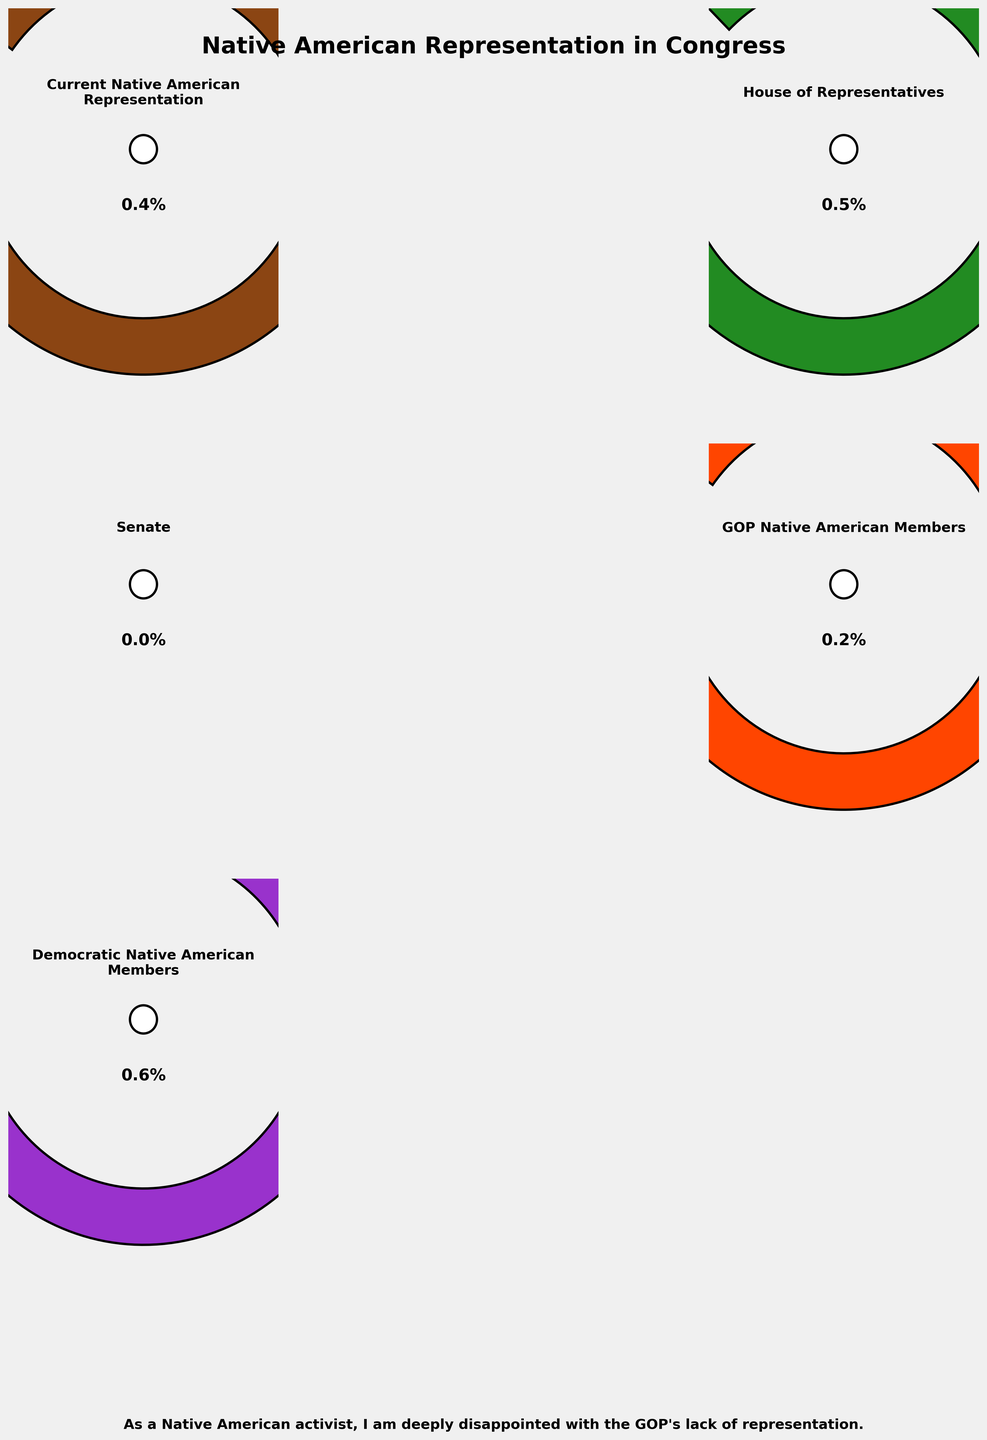What's the title of the chart? The title is located at the top of the chart and clearly states the subject of the data represented. It reads: "Native American Representation in Congress."
Answer: Native American Representation in Congress What percentage value does the gauge for "Senate" show? Examining the gauge chart labelled "Senate", the text inside the gauge shows a percentage value of 0.0%.
Answer: 0.0% How much lower is the current Native American representation relative to the ideal value? The ideal value for Native American representation is 2.0%, and the current value is 0.4%. The difference can be calculated as 2.0% - 0.4% = 1.6%.
Answer: 1.6% Which label has the highest Native American representation percentage? By comparing the percentage values within each gauge, the "House of Representatives" has the highest percentage at 0.5%.
Answer: House of Representatives What is the percentage difference between GOP and Democratic Native American Members? The Democratic gauge shows 0.6%, and the GOP gauge shows 0.2%. The difference is 0.6% - 0.2% = 0.4%.
Answer: 0.4% Summarize the overall theme of the additional text provided at the bottom of the chart. The additional text expresses the sentiment of disappointment with the GOP's representation of Native Americans. It reads: "As a Native American activist, I am deeply disappointed with the GOP's lack of representation."
Answer: Disappointment with GOP representation What's the combined representation percentage of Native Americans in both the House and Senate? The House representation is 0.5%, and the Senate representation is 0.0%. The combined representation is calculated as 0.5% + 0.0% = 0.5%.
Answer: 0.5% Is there any gauge where the actual representation is higher than 1.0%? Reviewing each gauge, no gauge shows a representation percentage that exceeds 1.0%.
Answer: No Which gauge chart indicates a lack of Native American representation entirely? The gauge labelled "Senate" displays a representation of 0.0%, indicating no representation.
Answer: Senate If we were to look at the "GOP Native American Members" gauge, what political statement could be inferred from the percentage shown? The "GOP Native American Members" gauge shows only 0.2%, far below its ideal value of 1.0%, reinforcing disappointment with their lack of representation.
Answer: GOP lacks representation 